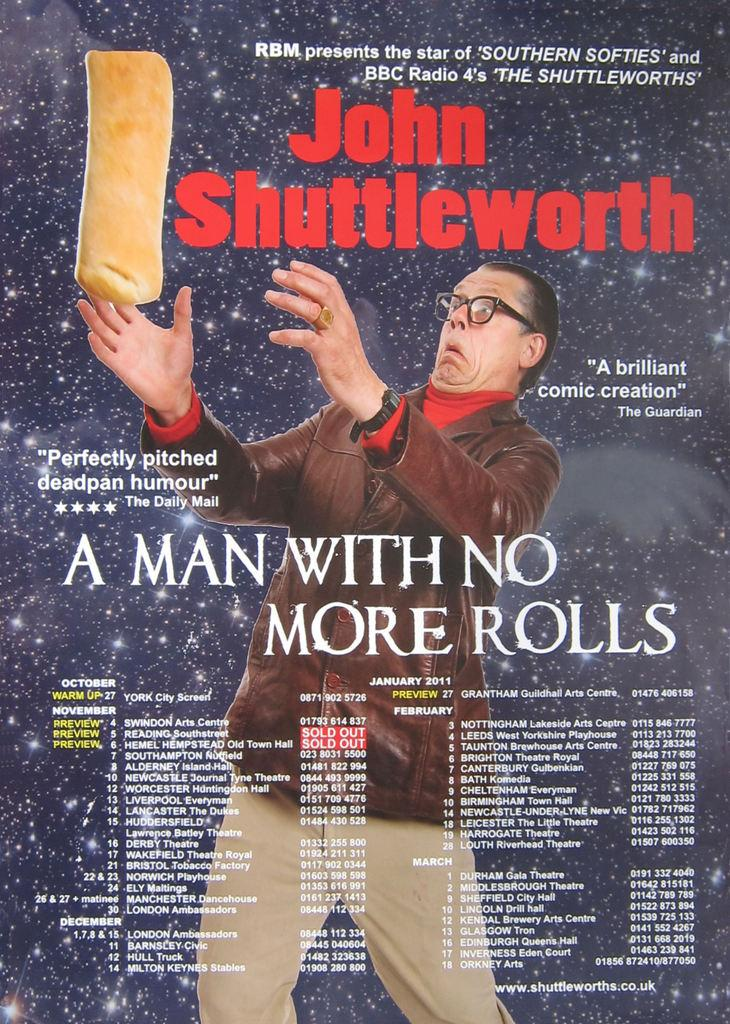What is present in the image? There is a man in the picture. What is the man doing in the image? The man is holding an object. Can you describe the object the man is holding? The object has writing on it and is the cover page of a book. How many cherries are on the bag in the image? There is no bag or cherries present in the image. What is the man's hand doing in the image? The provided facts do not mention the man's hand specifically, so we cannot answer this question definitively. 